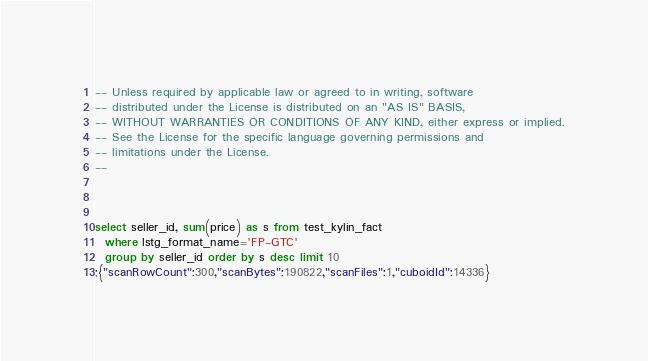<code> <loc_0><loc_0><loc_500><loc_500><_SQL_>-- Unless required by applicable law or agreed to in writing, software
-- distributed under the License is distributed on an "AS IS" BASIS,
-- WITHOUT WARRANTIES OR CONDITIONS OF ANY KIND, either express or implied.
-- See the License for the specific language governing permissions and
-- limitations under the License.
--



select seller_id, sum(price) as s from test_kylin_fact
  where lstg_format_name='FP-GTC' 
  group by seller_id order by s desc limit 10
;{"scanRowCount":300,"scanBytes":190822,"scanFiles":1,"cuboidId":14336}</code> 